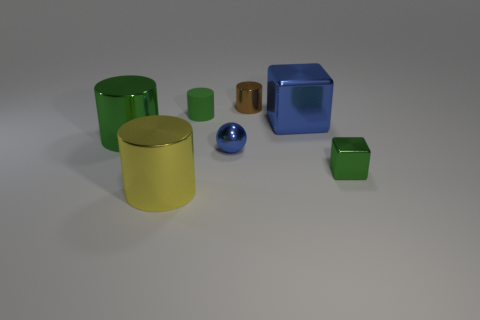Subtract all blue cylinders. Subtract all cyan blocks. How many cylinders are left? 4 Add 1 small cyan cylinders. How many objects exist? 8 Subtract all balls. How many objects are left? 6 Add 4 green rubber things. How many green rubber things are left? 5 Add 6 green objects. How many green objects exist? 9 Subtract 0 yellow balls. How many objects are left? 7 Subtract all big red things. Subtract all big blue things. How many objects are left? 6 